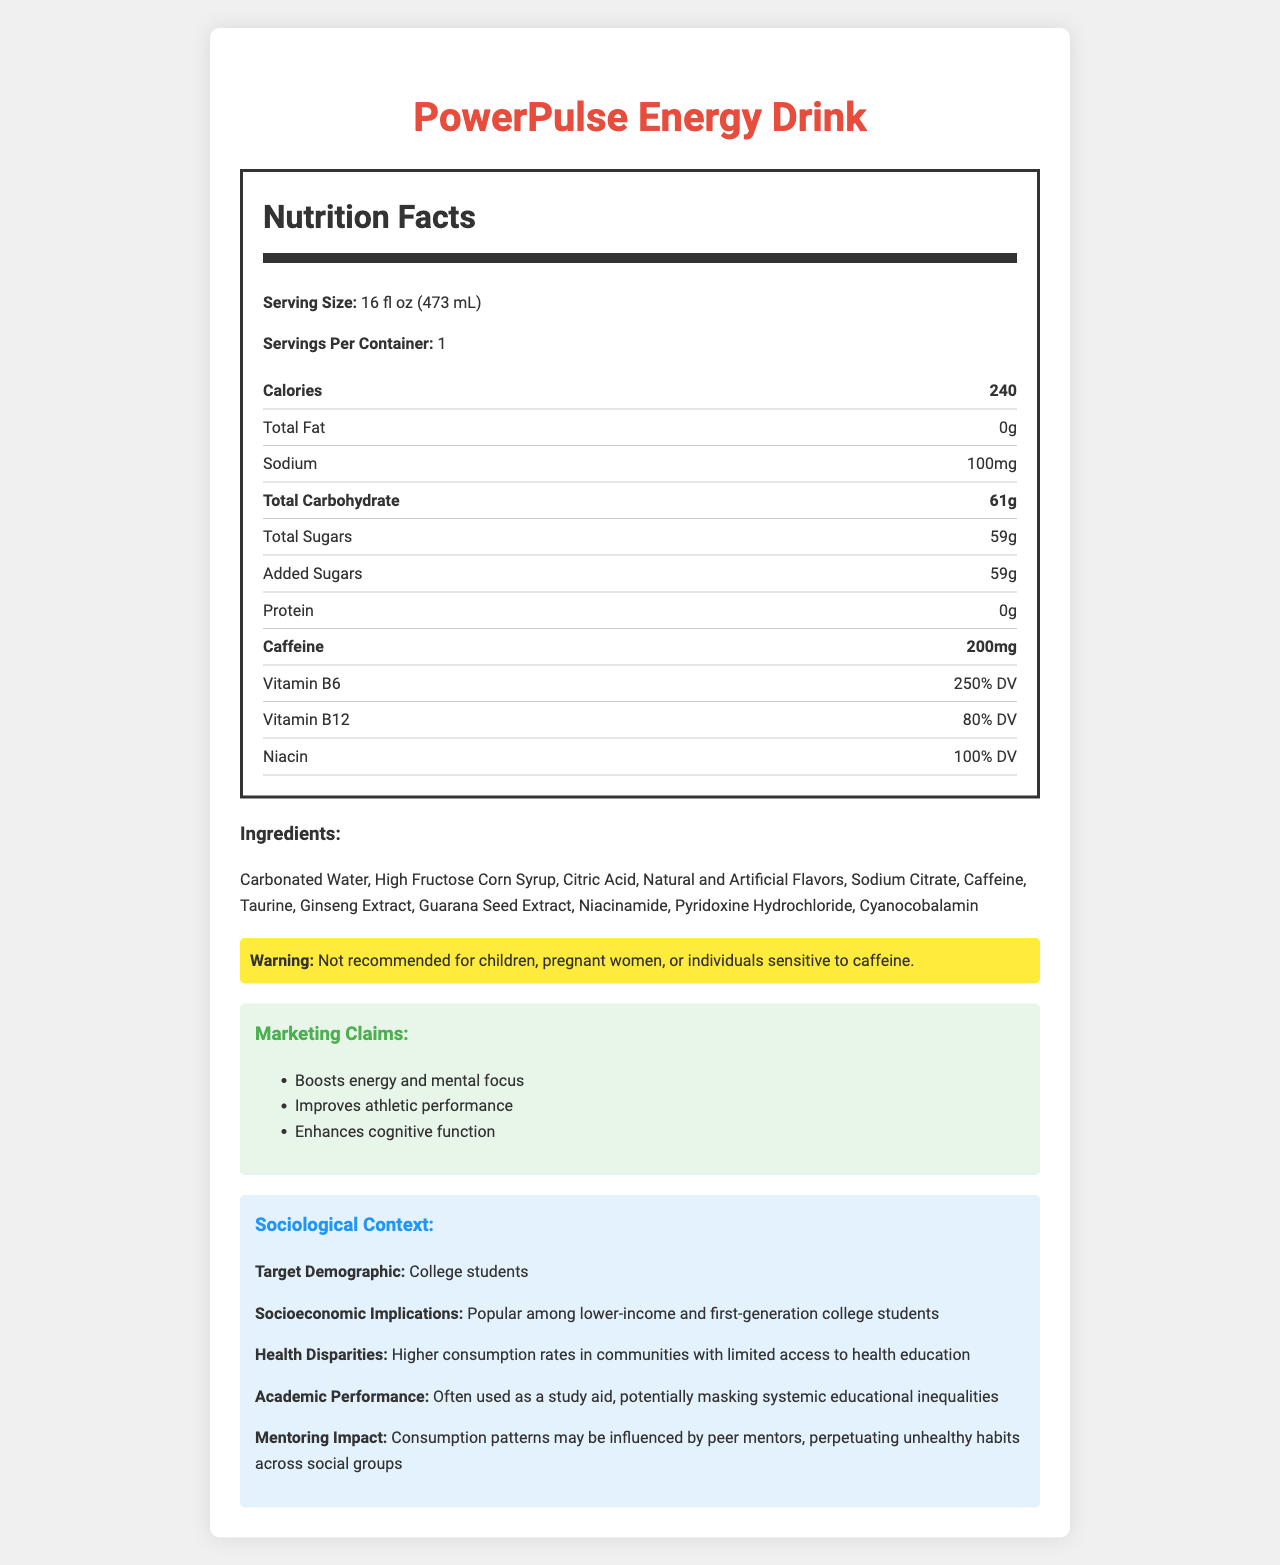what is the serving size for PowerPulse Energy Drink? The serving size is listed in the nutrition facts section at the beginning.
Answer: 16 fl oz (473 mL) how many calories are in one serving of PowerPulse Energy Drink? The calorie count is shown prominently in the nutrition facts section.
Answer: 240 how much caffeine is in one serving of this drink? The caffeine content is listed under the nutrition facts.
Answer: 200mg what is the total amount of sugar in one serving? The total sugars, including added sugars, are displayed in the nutrition facts section.
Answer: 59g what vitamins are included in the drink and their % DV? The vitamins and their percentages are detailed in the nutrition facts.
Answer: Vitamin B6: 250% DV, Vitamin B12: 80% DV, Niacin: 100% DV how many grams of protein does the drink contain? The protein amount is specified as 0g in the nutrition facts.
Answer: 0g what is the sociodemographic target of this drink? The sociological context section indicates the target demographic as college students.
Answer: College students who should avoid consuming this drink? A. Athletes B. Individuals sensitive to caffeine C. People over 40 D. Office workers The warning statement specifies that individuals sensitive to caffeine should avoid this drink.
Answer: B. Individuals sensitive to caffeine how does this drink affect academic performance according to the document? A. Improves grades B. Enhances memory retention C. Potentially masks systemic educational inequalities D. No impact The sociological context mentions that the drink is often used as a study aid, potentially masking systemic educational inequalities.
Answer: C. Potentially masks systemic educational inequalities is the drink recommended for pregnant women? The warning statement specifically notes that the drink is not recommended for pregnant women.
Answer: No can socio-economic implications influence the popularity of this energy drink? The sociological context states that this drink is popular among lower-income and first-generation college students, highlighting socio-economic factors.
Answer: Yes summarize the main idea of this document. The document outlines the nutritional details, cautionary warning, marketing claims, and sociological context of PowerPulse Energy Drink, focusing on its consumption patterns and health impacts.
Answer: The document provides the nutrition facts for PowerPulse Energy Drink, highlighting its high caffeine and sugar content, and discusses its sociological impacts, especially on college students, mentioning the potential health risks and socio-economic implications. what is the sodium content in one serving? The sodium content is listed in the nutrition facts section.
Answer: 100mg does the document specify the exact amount of ginseng extract in the drink? The document lists ginseng extract among the ingredients but does not specify the exact amount.
Answer: No how many servings are there per container? The nutrition facts section indicates that there is 1 serving per container.
Answer: 1 what is the primary marketing claim for this energy drink? The first marketing claim listed is that the drink boosts energy and mental focus.
Answer: Boosts energy and mental focus which ingredient is used as a sweetener in this drink? A. Aspartame B. High Fructose Corn Syrup C. Stevia D. Saccharin The ingredient list shows that High Fructose Corn Syrup is used as a sweetener in the drink.
Answer: B. High Fructose Corn Syrup 